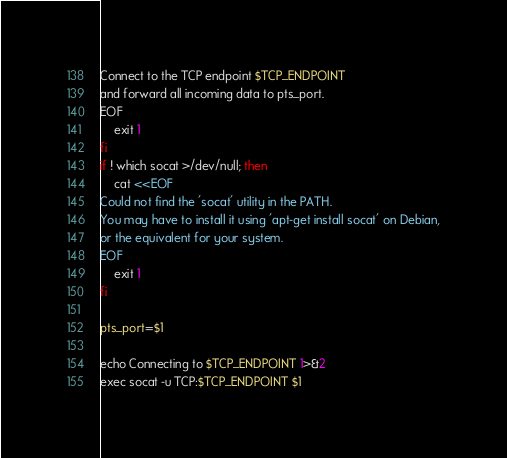Convert code to text. <code><loc_0><loc_0><loc_500><loc_500><_Bash_>Connect to the TCP endpoint $TCP_ENDPOINT
and forward all incoming data to pts_port.
EOF
	exit 1
fi
if ! which socat >/dev/null; then
	cat <<EOF
Could not find the 'socat' utility in the PATH.
You may have to install it using 'apt-get install socat' on Debian,
or the equivalent for your system.
EOF
	exit 1
fi

pts_port=$1

echo Connecting to $TCP_ENDPOINT 1>&2
exec socat -u TCP:$TCP_ENDPOINT $1
</code> 